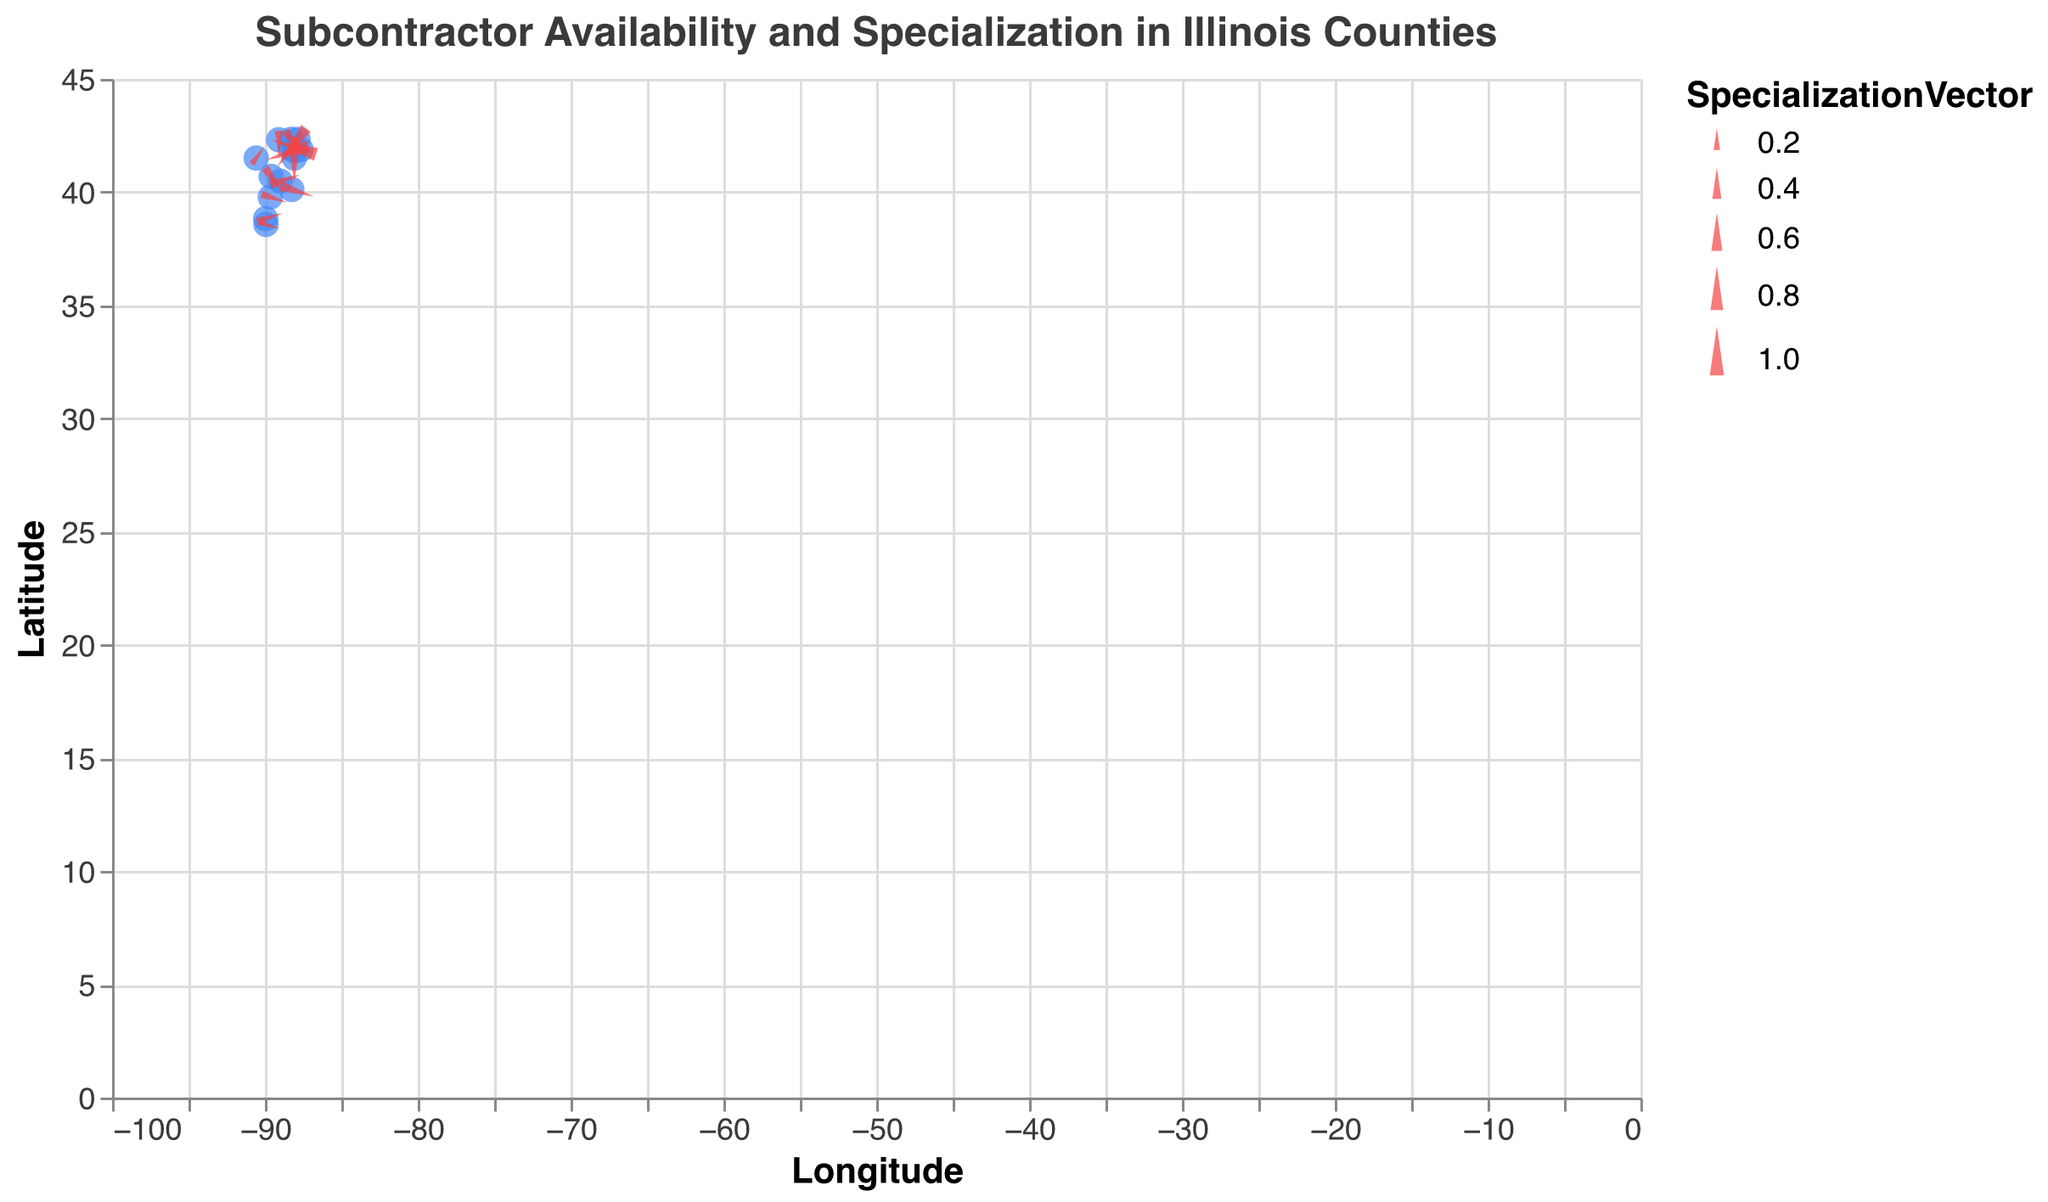What is the title of the plot? The title is displayed at the top of the plot. It reads "Subcontractor Availability and Specialization in Illinois Counties."
Answer: Subcontractor Availability and Specialization in Illinois Counties How many counties are represented in the plot? Each data point on the plot represents a county. There are 14 data points (counties) on the plot.
Answer: 14 Which county has the highest availability vector? By looking at the tooltip information or vectors, Cook County has the highest availability vector of 0.8.
Answer: Cook Which county has the lowest specialization vector? By looking at the tooltip information or vectors, St. Clair County has the lowest specialization vector of 0.2.
Answer: St. Clair What is the latitude and longitude of Peoria County? By hovering over the point corresponding to Peoria County on the plot, it shows a Latitude of 40.6936 and Longitude of -89.5890.
Answer: 40.6936, -89.5890 Which counties have an equal availability and specialization vector? By examining the vectors, McHenry and Peoria Counties both have equal availability and specialization vectors. McHenry - (0.4, 0.4), Peoria - (0.4, 0.4).
Answer: McHenry, Peoria Compare the availability vectors of Cook and DuPage counties. Which one is higher? By looking at the tooltip information, Cook has an availability vector of 0.8, and DuPage has an availability vector of 0.7. Cook's availability vector is higher.
Answer: Cook Which county shows the steepest increase in both vectors, when visualized as point size and angle? Cook County has the highest vectors for both availability (0.8) and specialization (0.9), which translates to a larger point size and a steeper angle.
Answer: Cook What is the average availability vector across all counties? Summing the availability vector values and dividing by the number of counties, (0.8 + 0.7 + 0.6 + 0.5 + 0.6 + 0.4 + 0.5 + 0.3 + 0.4 + 0.3 + 0.2 + 0.3 + 0.2 + 0.1) / 14 = 0.4143.
Answer: 0.4143 What general trend do you notice between the latitude and the specialization vector? As the latitude decreases, there is a general trend that the specialization vector also tends to decrease. This is observed by examining the points representing counties from north to south (e.g., Cook to St. Clair).
Answer: Decreasing specialization vector with latitude 